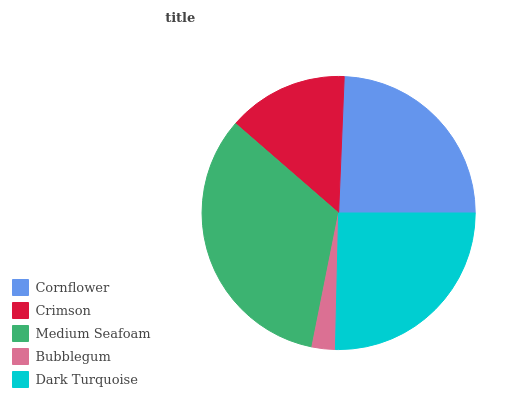Is Bubblegum the minimum?
Answer yes or no. Yes. Is Medium Seafoam the maximum?
Answer yes or no. Yes. Is Crimson the minimum?
Answer yes or no. No. Is Crimson the maximum?
Answer yes or no. No. Is Cornflower greater than Crimson?
Answer yes or no. Yes. Is Crimson less than Cornflower?
Answer yes or no. Yes. Is Crimson greater than Cornflower?
Answer yes or no. No. Is Cornflower less than Crimson?
Answer yes or no. No. Is Cornflower the high median?
Answer yes or no. Yes. Is Cornflower the low median?
Answer yes or no. Yes. Is Dark Turquoise the high median?
Answer yes or no. No. Is Bubblegum the low median?
Answer yes or no. No. 